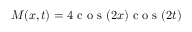Convert formula to latex. <formula><loc_0><loc_0><loc_500><loc_500>M ( x , t ) = 4 c o s ( 2 x ) c o s ( 2 t )</formula> 